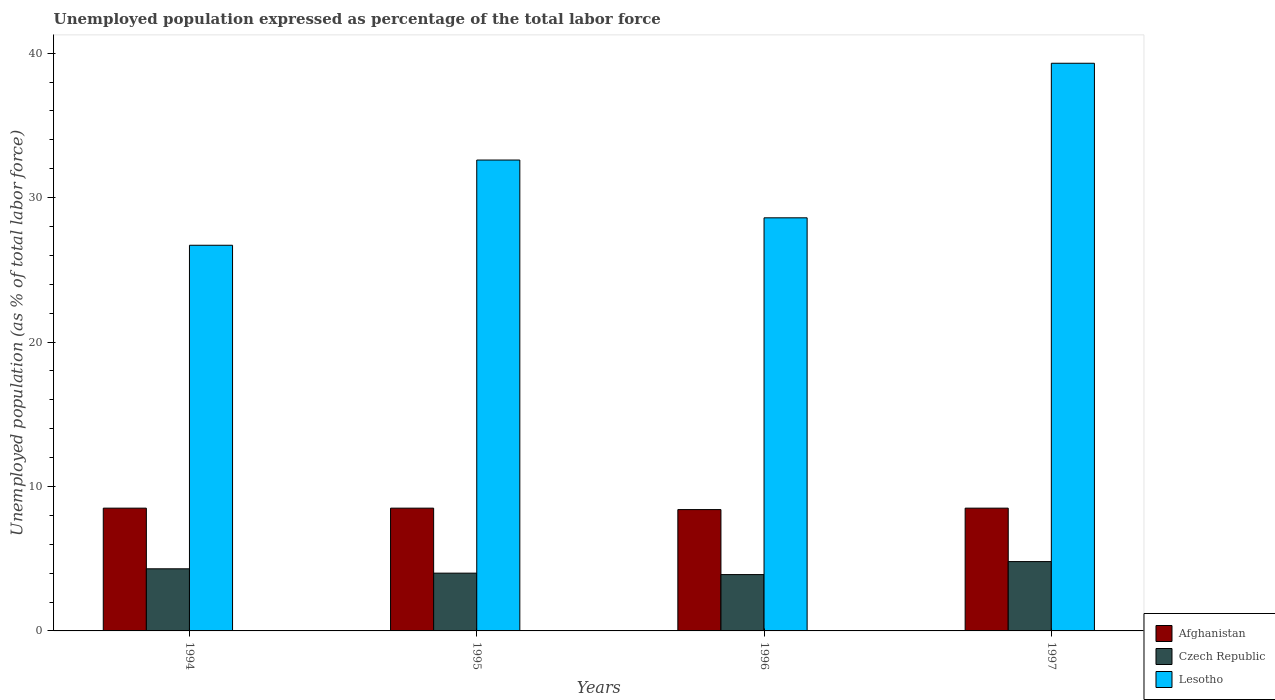How many different coloured bars are there?
Provide a succinct answer. 3. Are the number of bars on each tick of the X-axis equal?
Your answer should be very brief. Yes. How many bars are there on the 1st tick from the left?
Ensure brevity in your answer.  3. What is the label of the 1st group of bars from the left?
Provide a succinct answer. 1994. What is the unemployment in in Afghanistan in 1995?
Provide a short and direct response. 8.5. Across all years, what is the maximum unemployment in in Lesotho?
Your answer should be compact. 39.3. Across all years, what is the minimum unemployment in in Lesotho?
Ensure brevity in your answer.  26.7. What is the total unemployment in in Afghanistan in the graph?
Provide a succinct answer. 33.9. What is the difference between the unemployment in in Lesotho in 1995 and that in 1996?
Your response must be concise. 4. What is the difference between the unemployment in in Lesotho in 1994 and the unemployment in in Afghanistan in 1995?
Keep it short and to the point. 18.2. What is the average unemployment in in Czech Republic per year?
Provide a short and direct response. 4.25. In the year 1996, what is the difference between the unemployment in in Czech Republic and unemployment in in Lesotho?
Provide a succinct answer. -24.7. In how many years, is the unemployment in in Lesotho greater than 32 %?
Offer a very short reply. 2. What is the ratio of the unemployment in in Lesotho in 1995 to that in 1996?
Give a very brief answer. 1.14. Is the unemployment in in Afghanistan in 1996 less than that in 1997?
Your answer should be very brief. Yes. What is the difference between the highest and the lowest unemployment in in Czech Republic?
Your answer should be compact. 0.9. Is the sum of the unemployment in in Afghanistan in 1994 and 1996 greater than the maximum unemployment in in Lesotho across all years?
Give a very brief answer. No. What does the 2nd bar from the left in 1997 represents?
Keep it short and to the point. Czech Republic. What does the 3rd bar from the right in 1994 represents?
Provide a short and direct response. Afghanistan. Is it the case that in every year, the sum of the unemployment in in Czech Republic and unemployment in in Afghanistan is greater than the unemployment in in Lesotho?
Your answer should be very brief. No. How many bars are there?
Ensure brevity in your answer.  12. How many years are there in the graph?
Keep it short and to the point. 4. What is the difference between two consecutive major ticks on the Y-axis?
Make the answer very short. 10. Are the values on the major ticks of Y-axis written in scientific E-notation?
Provide a succinct answer. No. Does the graph contain any zero values?
Offer a terse response. No. Does the graph contain grids?
Offer a very short reply. No. Where does the legend appear in the graph?
Keep it short and to the point. Bottom right. How many legend labels are there?
Keep it short and to the point. 3. What is the title of the graph?
Give a very brief answer. Unemployed population expressed as percentage of the total labor force. What is the label or title of the X-axis?
Your answer should be very brief. Years. What is the label or title of the Y-axis?
Give a very brief answer. Unemployed population (as % of total labor force). What is the Unemployed population (as % of total labor force) in Czech Republic in 1994?
Give a very brief answer. 4.3. What is the Unemployed population (as % of total labor force) of Lesotho in 1994?
Your response must be concise. 26.7. What is the Unemployed population (as % of total labor force) of Afghanistan in 1995?
Make the answer very short. 8.5. What is the Unemployed population (as % of total labor force) in Czech Republic in 1995?
Keep it short and to the point. 4. What is the Unemployed population (as % of total labor force) in Lesotho in 1995?
Offer a very short reply. 32.6. What is the Unemployed population (as % of total labor force) in Afghanistan in 1996?
Your answer should be very brief. 8.4. What is the Unemployed population (as % of total labor force) in Czech Republic in 1996?
Your response must be concise. 3.9. What is the Unemployed population (as % of total labor force) of Lesotho in 1996?
Your answer should be very brief. 28.6. What is the Unemployed population (as % of total labor force) of Czech Republic in 1997?
Your response must be concise. 4.8. What is the Unemployed population (as % of total labor force) of Lesotho in 1997?
Give a very brief answer. 39.3. Across all years, what is the maximum Unemployed population (as % of total labor force) of Afghanistan?
Ensure brevity in your answer.  8.5. Across all years, what is the maximum Unemployed population (as % of total labor force) of Czech Republic?
Provide a succinct answer. 4.8. Across all years, what is the maximum Unemployed population (as % of total labor force) in Lesotho?
Your answer should be compact. 39.3. Across all years, what is the minimum Unemployed population (as % of total labor force) of Afghanistan?
Keep it short and to the point. 8.4. Across all years, what is the minimum Unemployed population (as % of total labor force) of Czech Republic?
Your answer should be compact. 3.9. Across all years, what is the minimum Unemployed population (as % of total labor force) of Lesotho?
Your answer should be very brief. 26.7. What is the total Unemployed population (as % of total labor force) in Afghanistan in the graph?
Your answer should be compact. 33.9. What is the total Unemployed population (as % of total labor force) of Czech Republic in the graph?
Offer a terse response. 17. What is the total Unemployed population (as % of total labor force) in Lesotho in the graph?
Ensure brevity in your answer.  127.2. What is the difference between the Unemployed population (as % of total labor force) of Lesotho in 1994 and that in 1995?
Give a very brief answer. -5.9. What is the difference between the Unemployed population (as % of total labor force) of Afghanistan in 1994 and that in 1997?
Your response must be concise. 0. What is the difference between the Unemployed population (as % of total labor force) of Lesotho in 1994 and that in 1997?
Keep it short and to the point. -12.6. What is the difference between the Unemployed population (as % of total labor force) of Afghanistan in 1995 and that in 1996?
Your response must be concise. 0.1. What is the difference between the Unemployed population (as % of total labor force) of Czech Republic in 1995 and that in 1996?
Offer a terse response. 0.1. What is the difference between the Unemployed population (as % of total labor force) in Lesotho in 1995 and that in 1996?
Make the answer very short. 4. What is the difference between the Unemployed population (as % of total labor force) of Afghanistan in 1995 and that in 1997?
Offer a terse response. 0. What is the difference between the Unemployed population (as % of total labor force) of Afghanistan in 1996 and that in 1997?
Make the answer very short. -0.1. What is the difference between the Unemployed population (as % of total labor force) in Czech Republic in 1996 and that in 1997?
Offer a terse response. -0.9. What is the difference between the Unemployed population (as % of total labor force) in Afghanistan in 1994 and the Unemployed population (as % of total labor force) in Lesotho in 1995?
Your answer should be very brief. -24.1. What is the difference between the Unemployed population (as % of total labor force) of Czech Republic in 1994 and the Unemployed population (as % of total labor force) of Lesotho in 1995?
Keep it short and to the point. -28.3. What is the difference between the Unemployed population (as % of total labor force) in Afghanistan in 1994 and the Unemployed population (as % of total labor force) in Lesotho in 1996?
Provide a short and direct response. -20.1. What is the difference between the Unemployed population (as % of total labor force) in Czech Republic in 1994 and the Unemployed population (as % of total labor force) in Lesotho in 1996?
Keep it short and to the point. -24.3. What is the difference between the Unemployed population (as % of total labor force) in Afghanistan in 1994 and the Unemployed population (as % of total labor force) in Lesotho in 1997?
Ensure brevity in your answer.  -30.8. What is the difference between the Unemployed population (as % of total labor force) of Czech Republic in 1994 and the Unemployed population (as % of total labor force) of Lesotho in 1997?
Keep it short and to the point. -35. What is the difference between the Unemployed population (as % of total labor force) of Afghanistan in 1995 and the Unemployed population (as % of total labor force) of Lesotho in 1996?
Provide a succinct answer. -20.1. What is the difference between the Unemployed population (as % of total labor force) in Czech Republic in 1995 and the Unemployed population (as % of total labor force) in Lesotho in 1996?
Your response must be concise. -24.6. What is the difference between the Unemployed population (as % of total labor force) in Afghanistan in 1995 and the Unemployed population (as % of total labor force) in Czech Republic in 1997?
Provide a short and direct response. 3.7. What is the difference between the Unemployed population (as % of total labor force) in Afghanistan in 1995 and the Unemployed population (as % of total labor force) in Lesotho in 1997?
Ensure brevity in your answer.  -30.8. What is the difference between the Unemployed population (as % of total labor force) in Czech Republic in 1995 and the Unemployed population (as % of total labor force) in Lesotho in 1997?
Offer a terse response. -35.3. What is the difference between the Unemployed population (as % of total labor force) in Afghanistan in 1996 and the Unemployed population (as % of total labor force) in Lesotho in 1997?
Keep it short and to the point. -30.9. What is the difference between the Unemployed population (as % of total labor force) of Czech Republic in 1996 and the Unemployed population (as % of total labor force) of Lesotho in 1997?
Your answer should be compact. -35.4. What is the average Unemployed population (as % of total labor force) of Afghanistan per year?
Offer a terse response. 8.47. What is the average Unemployed population (as % of total labor force) of Czech Republic per year?
Give a very brief answer. 4.25. What is the average Unemployed population (as % of total labor force) in Lesotho per year?
Offer a terse response. 31.8. In the year 1994, what is the difference between the Unemployed population (as % of total labor force) of Afghanistan and Unemployed population (as % of total labor force) of Lesotho?
Your answer should be very brief. -18.2. In the year 1994, what is the difference between the Unemployed population (as % of total labor force) in Czech Republic and Unemployed population (as % of total labor force) in Lesotho?
Give a very brief answer. -22.4. In the year 1995, what is the difference between the Unemployed population (as % of total labor force) of Afghanistan and Unemployed population (as % of total labor force) of Czech Republic?
Give a very brief answer. 4.5. In the year 1995, what is the difference between the Unemployed population (as % of total labor force) of Afghanistan and Unemployed population (as % of total labor force) of Lesotho?
Provide a succinct answer. -24.1. In the year 1995, what is the difference between the Unemployed population (as % of total labor force) in Czech Republic and Unemployed population (as % of total labor force) in Lesotho?
Make the answer very short. -28.6. In the year 1996, what is the difference between the Unemployed population (as % of total labor force) in Afghanistan and Unemployed population (as % of total labor force) in Lesotho?
Offer a terse response. -20.2. In the year 1996, what is the difference between the Unemployed population (as % of total labor force) in Czech Republic and Unemployed population (as % of total labor force) in Lesotho?
Provide a short and direct response. -24.7. In the year 1997, what is the difference between the Unemployed population (as % of total labor force) of Afghanistan and Unemployed population (as % of total labor force) of Lesotho?
Ensure brevity in your answer.  -30.8. In the year 1997, what is the difference between the Unemployed population (as % of total labor force) of Czech Republic and Unemployed population (as % of total labor force) of Lesotho?
Give a very brief answer. -34.5. What is the ratio of the Unemployed population (as % of total labor force) of Czech Republic in 1994 to that in 1995?
Your answer should be compact. 1.07. What is the ratio of the Unemployed population (as % of total labor force) of Lesotho in 1994 to that in 1995?
Provide a short and direct response. 0.82. What is the ratio of the Unemployed population (as % of total labor force) in Afghanistan in 1994 to that in 1996?
Your answer should be compact. 1.01. What is the ratio of the Unemployed population (as % of total labor force) in Czech Republic in 1994 to that in 1996?
Give a very brief answer. 1.1. What is the ratio of the Unemployed population (as % of total labor force) of Lesotho in 1994 to that in 1996?
Your response must be concise. 0.93. What is the ratio of the Unemployed population (as % of total labor force) in Czech Republic in 1994 to that in 1997?
Your response must be concise. 0.9. What is the ratio of the Unemployed population (as % of total labor force) in Lesotho in 1994 to that in 1997?
Ensure brevity in your answer.  0.68. What is the ratio of the Unemployed population (as % of total labor force) in Afghanistan in 1995 to that in 1996?
Offer a very short reply. 1.01. What is the ratio of the Unemployed population (as % of total labor force) in Czech Republic in 1995 to that in 1996?
Your response must be concise. 1.03. What is the ratio of the Unemployed population (as % of total labor force) of Lesotho in 1995 to that in 1996?
Your answer should be compact. 1.14. What is the ratio of the Unemployed population (as % of total labor force) in Afghanistan in 1995 to that in 1997?
Your answer should be compact. 1. What is the ratio of the Unemployed population (as % of total labor force) of Lesotho in 1995 to that in 1997?
Make the answer very short. 0.83. What is the ratio of the Unemployed population (as % of total labor force) in Czech Republic in 1996 to that in 1997?
Ensure brevity in your answer.  0.81. What is the ratio of the Unemployed population (as % of total labor force) in Lesotho in 1996 to that in 1997?
Your response must be concise. 0.73. What is the difference between the highest and the second highest Unemployed population (as % of total labor force) of Afghanistan?
Your answer should be very brief. 0. What is the difference between the highest and the second highest Unemployed population (as % of total labor force) in Czech Republic?
Offer a terse response. 0.5. What is the difference between the highest and the second highest Unemployed population (as % of total labor force) in Lesotho?
Ensure brevity in your answer.  6.7. What is the difference between the highest and the lowest Unemployed population (as % of total labor force) in Afghanistan?
Make the answer very short. 0.1. What is the difference between the highest and the lowest Unemployed population (as % of total labor force) of Czech Republic?
Your answer should be compact. 0.9. 